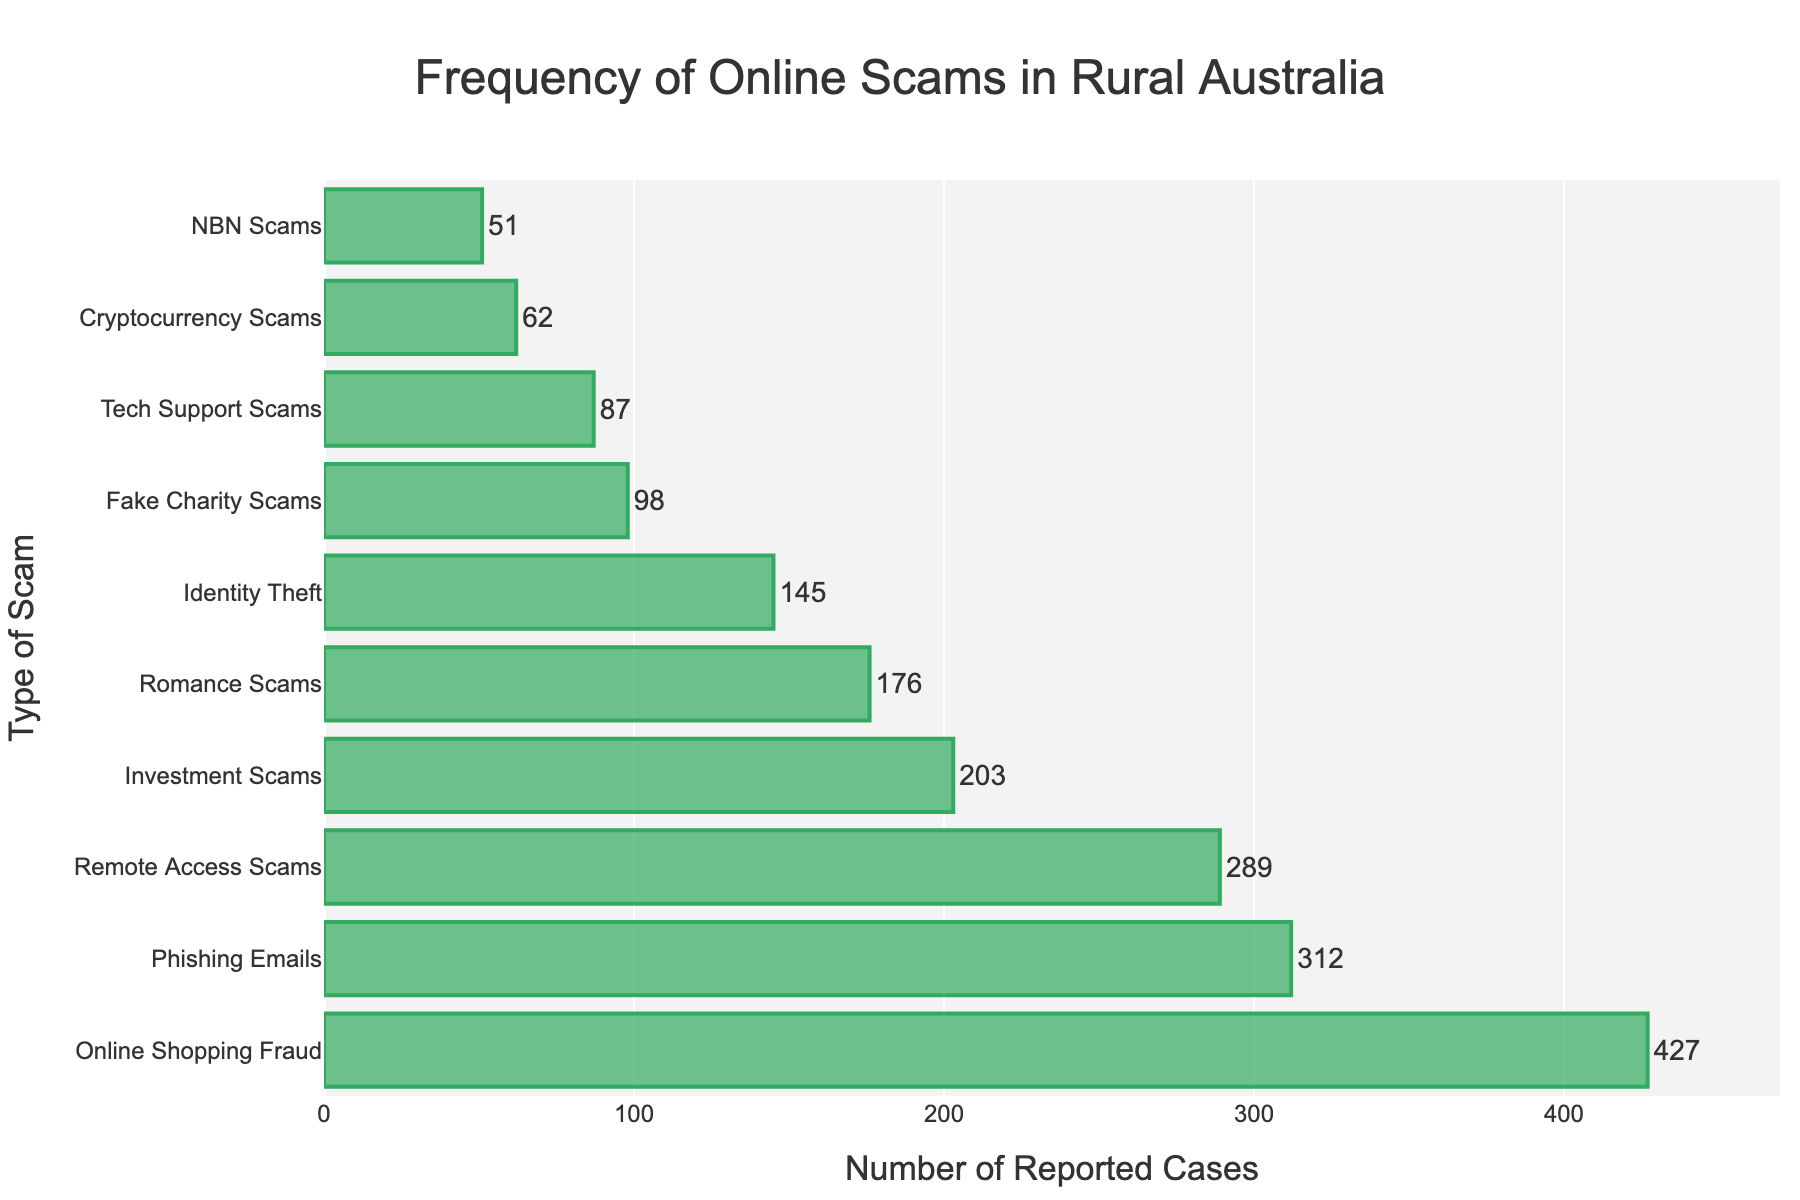Which type of scam has the highest number of reported cases? By examining the length of the horizontal bars, the longest bar represents the type of scam with the most reported cases. The "Online Shopping Fraud" bar is the longest.
Answer: Online Shopping Fraud How many reported cases are there for Phishing Emails? Locate the bar labeled "Phishing Emails" and read the number of reported cases displayed along the x-axis or the text at the end of the bar.
Answer: 312 Which scam type has the least reported cases? The shortest bar on the plot corresponds to the scam type with the fewest reported cases. "NBN Scams" has the shortest bar.
Answer: NBN Scams What is the difference in the number of reported cases between Investment Scams and Cryptocurrency Scams? Find the bars for Investment Scams and Cryptocurrency Scams and subtract the number of reported cases of Cryptocurrency Scams from Investment Scams. Investment Scams have 203 cases, and Cryptocurrency Scams have 62 cases. The difference is 203 - 62 = 141.
Answer: 141 How many total cases are reported for Remote Access Scams, Romance Scams, and Identity Theft combined? Add the number of reported cases for each of these scam types. Remote Access Scams have 289 cases, Romance Scams have 176 cases, and Identity Theft has 145 cases. The total is 289 + 176 + 145 = 610.
Answer: 610 Are there more reported cases of Fake Charity Scams or Tech Support Scams? Compare the bar lengths or the numerical values for Fake Charity Scams and Tech Support Scams. Fake Charity Scams have 98 cases, whereas Tech Support Scams have 87 cases.
Answer: Fake Charity Scams What is the average number of reported cases per scam type? Sum the reported cases for all scam types and divide by the total number of scam types. Sum of cases is 1450 and there are 10 scam types. The average is 1450 / 10 = 145.
Answer: 145 How many more reported cases are there for Online Shopping Fraud compared to Romance Scams? Subtract the number of reported cases of Romance Scams from Online Shopping Fraud. Online Shopping Fraud has 427 cases, and Romance Scams have 176 cases. The difference is 427 - 176 = 251.
Answer: 251 